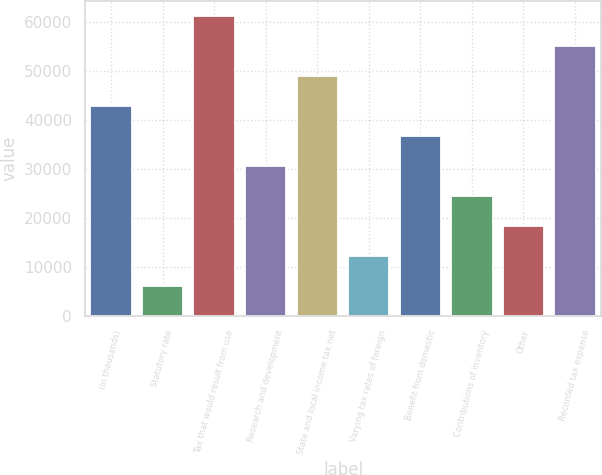Convert chart. <chart><loc_0><loc_0><loc_500><loc_500><bar_chart><fcel>(in thousands)<fcel>Statutory rate<fcel>Tax that would result from use<fcel>Research and development<fcel>State and local income tax net<fcel>Varying tax rates of foreign<fcel>Benefit from domestic<fcel>Contributions of inventory<fcel>Other<fcel>Recorded tax expense<nl><fcel>42877.6<fcel>6150.92<fcel>61241<fcel>30635.4<fcel>48998.8<fcel>12272<fcel>36756.5<fcel>24514.3<fcel>18393.2<fcel>55119.9<nl></chart> 